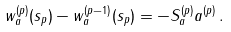<formula> <loc_0><loc_0><loc_500><loc_500>w _ { a } ^ { ( p ) } ( s _ { p } ) - w _ { a } ^ { ( p - 1 ) } ( s _ { p } ) = - S _ { a } ^ { ( p ) } a ^ { ( p ) } \, .</formula> 